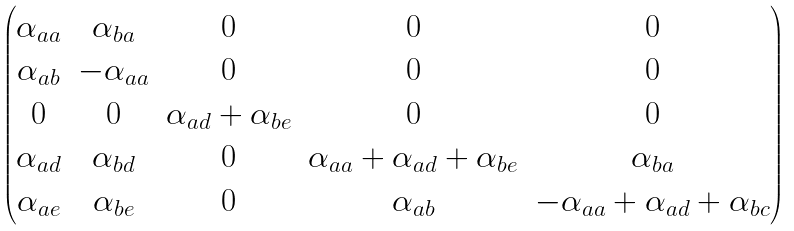Convert formula to latex. <formula><loc_0><loc_0><loc_500><loc_500>\begin{pmatrix} \alpha _ { a a } & \alpha _ { b a } & 0 & 0 & 0 \\ \alpha _ { a b } & - \alpha _ { a a } & 0 & 0 & 0 \\ 0 & 0 & \alpha _ { a d } + \alpha _ { b e } & 0 & 0 \\ \alpha _ { a d } & \alpha _ { b d } & 0 & \alpha _ { a a } + \alpha _ { a d } + \alpha _ { b e } & \alpha _ { b a } \\ \alpha _ { a e } & \alpha _ { b e } & 0 & \alpha _ { a b } & - \alpha _ { a a } + \alpha _ { a d } + \alpha _ { b c } \end{pmatrix}</formula> 